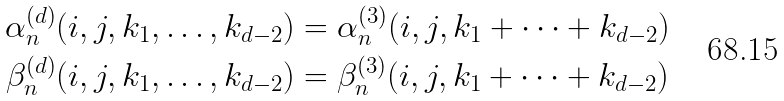Convert formula to latex. <formula><loc_0><loc_0><loc_500><loc_500>\alpha _ { n } ^ { ( d ) } ( i , j , k _ { 1 } , \dots , k _ { d - 2 } ) & = \alpha _ { n } ^ { ( 3 ) } ( i , j , k _ { 1 } + \cdots + k _ { d - 2 } ) \\ \beta _ { n } ^ { ( d ) } ( i , j , k _ { 1 } , \dots , k _ { d - 2 } ) & = \beta _ { n } ^ { ( 3 ) } ( i , j , k _ { 1 } + \cdots + k _ { d - 2 } )</formula> 